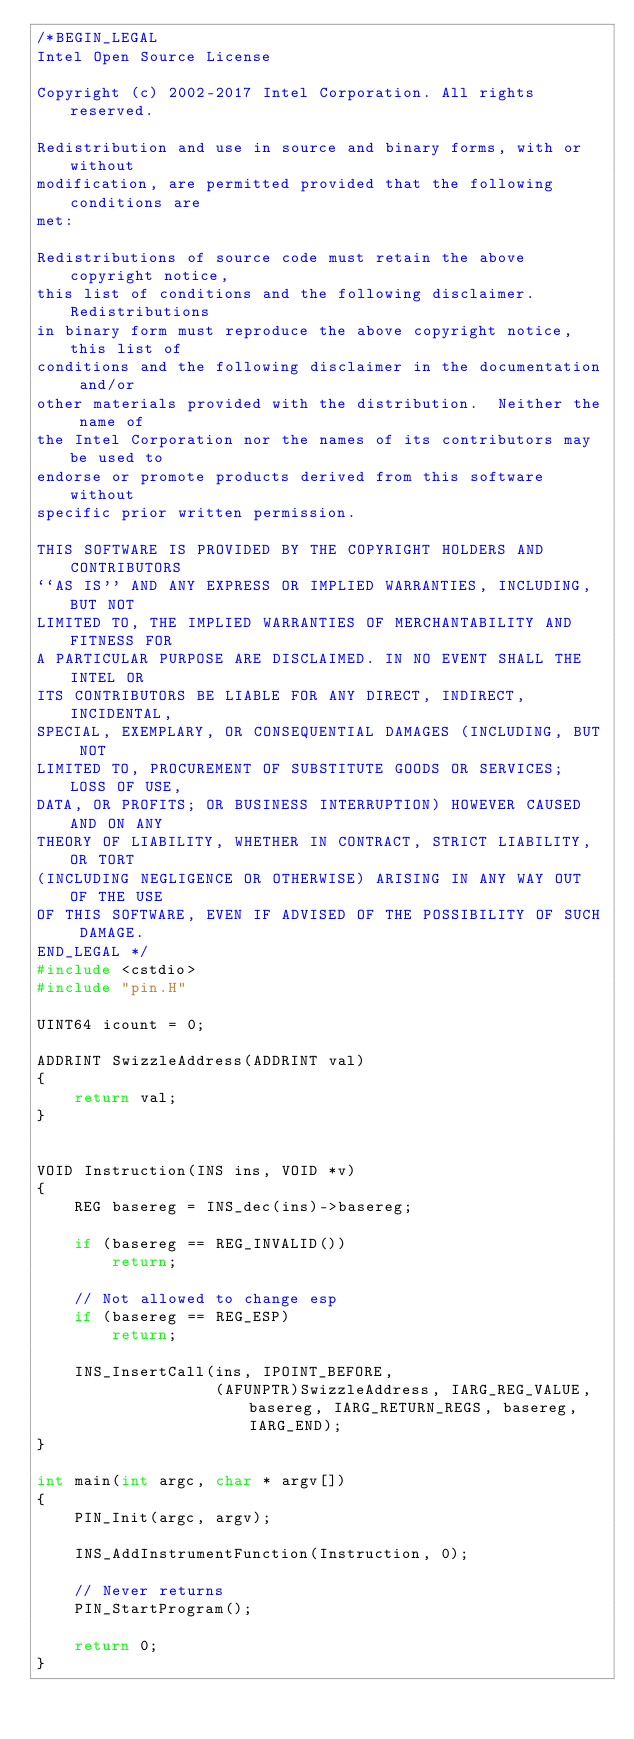Convert code to text. <code><loc_0><loc_0><loc_500><loc_500><_C++_>/*BEGIN_LEGAL 
Intel Open Source License 

Copyright (c) 2002-2017 Intel Corporation. All rights reserved.
 
Redistribution and use in source and binary forms, with or without
modification, are permitted provided that the following conditions are
met:

Redistributions of source code must retain the above copyright notice,
this list of conditions and the following disclaimer.  Redistributions
in binary form must reproduce the above copyright notice, this list of
conditions and the following disclaimer in the documentation and/or
other materials provided with the distribution.  Neither the name of
the Intel Corporation nor the names of its contributors may be used to
endorse or promote products derived from this software without
specific prior written permission.
 
THIS SOFTWARE IS PROVIDED BY THE COPYRIGHT HOLDERS AND CONTRIBUTORS
``AS IS'' AND ANY EXPRESS OR IMPLIED WARRANTIES, INCLUDING, BUT NOT
LIMITED TO, THE IMPLIED WARRANTIES OF MERCHANTABILITY AND FITNESS FOR
A PARTICULAR PURPOSE ARE DISCLAIMED. IN NO EVENT SHALL THE INTEL OR
ITS CONTRIBUTORS BE LIABLE FOR ANY DIRECT, INDIRECT, INCIDENTAL,
SPECIAL, EXEMPLARY, OR CONSEQUENTIAL DAMAGES (INCLUDING, BUT NOT
LIMITED TO, PROCUREMENT OF SUBSTITUTE GOODS OR SERVICES; LOSS OF USE,
DATA, OR PROFITS; OR BUSINESS INTERRUPTION) HOWEVER CAUSED AND ON ANY
THEORY OF LIABILITY, WHETHER IN CONTRACT, STRICT LIABILITY, OR TORT
(INCLUDING NEGLIGENCE OR OTHERWISE) ARISING IN ANY WAY OUT OF THE USE
OF THIS SOFTWARE, EVEN IF ADVISED OF THE POSSIBILITY OF SUCH DAMAGE.
END_LEGAL */
#include <cstdio>
#include "pin.H"

UINT64 icount = 0;

ADDRINT SwizzleAddress(ADDRINT val)
{
    return val;
}


VOID Instruction(INS ins, VOID *v)
{
    REG basereg = INS_dec(ins)->basereg;

    if (basereg == REG_INVALID())
        return;

    // Not allowed to change esp
    if (basereg == REG_ESP)
        return;

    INS_InsertCall(ins, IPOINT_BEFORE,
                   (AFUNPTR)SwizzleAddress, IARG_REG_VALUE, basereg, IARG_RETURN_REGS, basereg, IARG_END);
}

int main(int argc, char * argv[])
{
    PIN_Init(argc, argv);

    INS_AddInstrumentFunction(Instruction, 0);

    // Never returns
    PIN_StartProgram();

    return 0;
}
</code> 